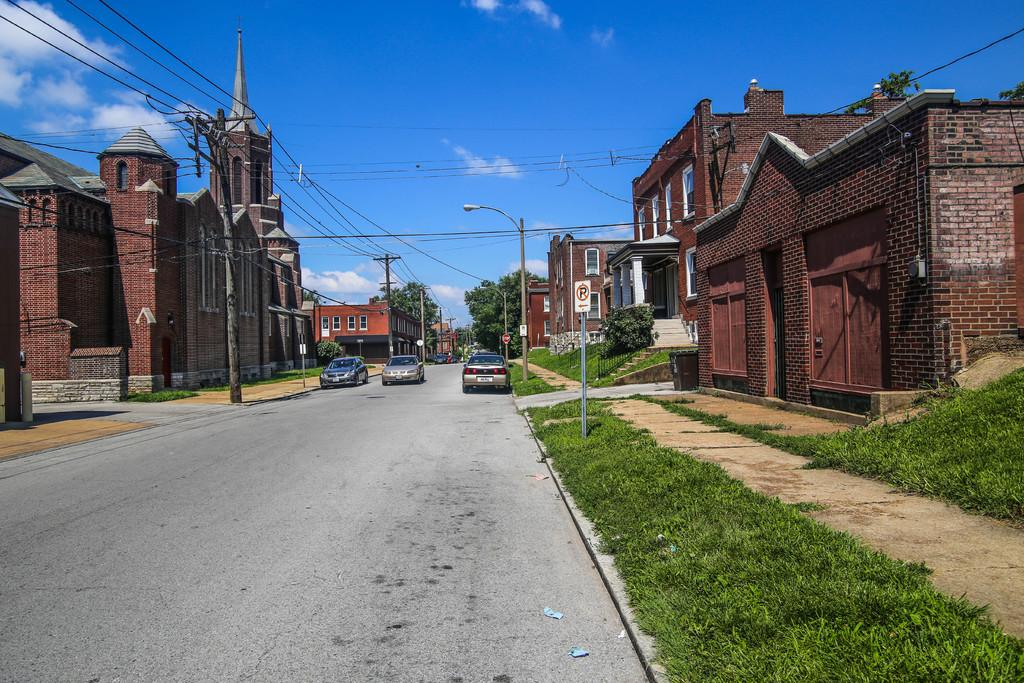<image>
Write a terse but informative summary of the picture. a no parking sign on the side of a very large street 